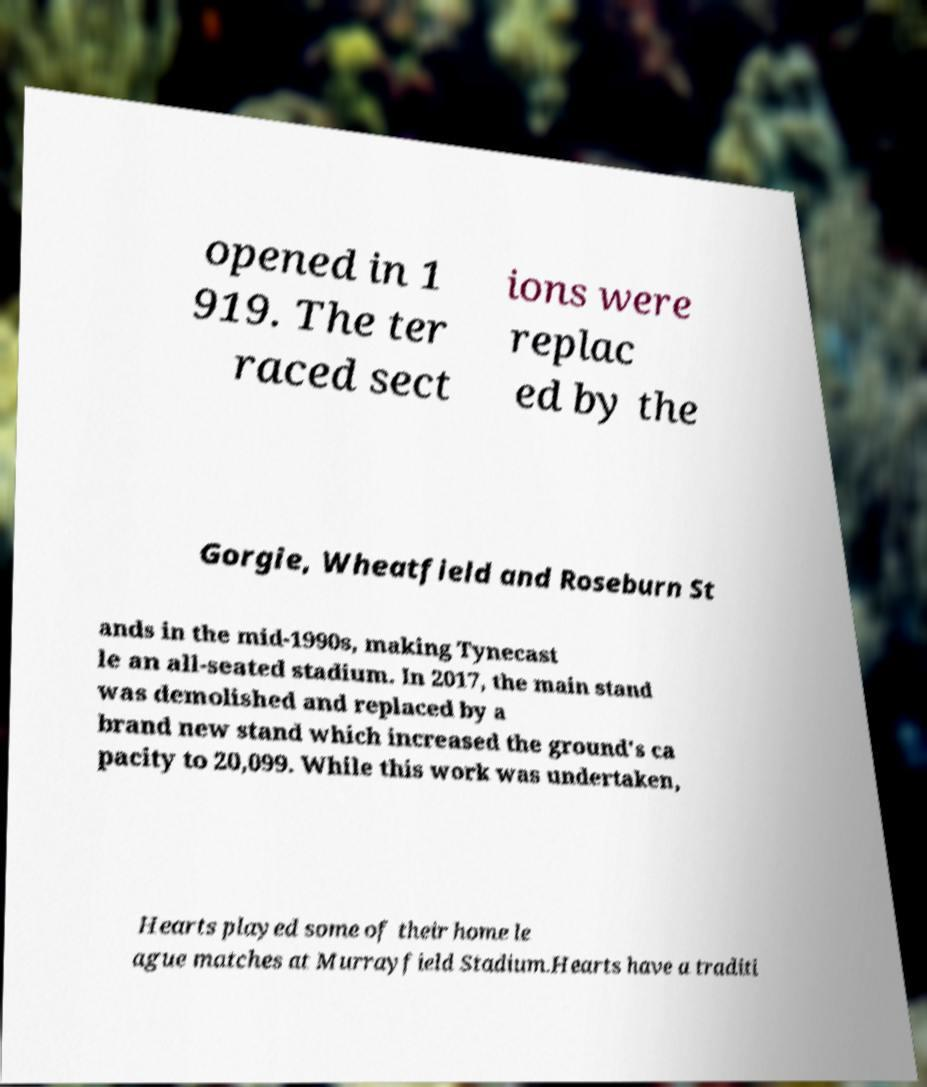What messages or text are displayed in this image? I need them in a readable, typed format. opened in 1 919. The ter raced sect ions were replac ed by the Gorgie, Wheatfield and Roseburn St ands in the mid-1990s, making Tynecast le an all-seated stadium. In 2017, the main stand was demolished and replaced by a brand new stand which increased the ground's ca pacity to 20,099. While this work was undertaken, Hearts played some of their home le ague matches at Murrayfield Stadium.Hearts have a traditi 